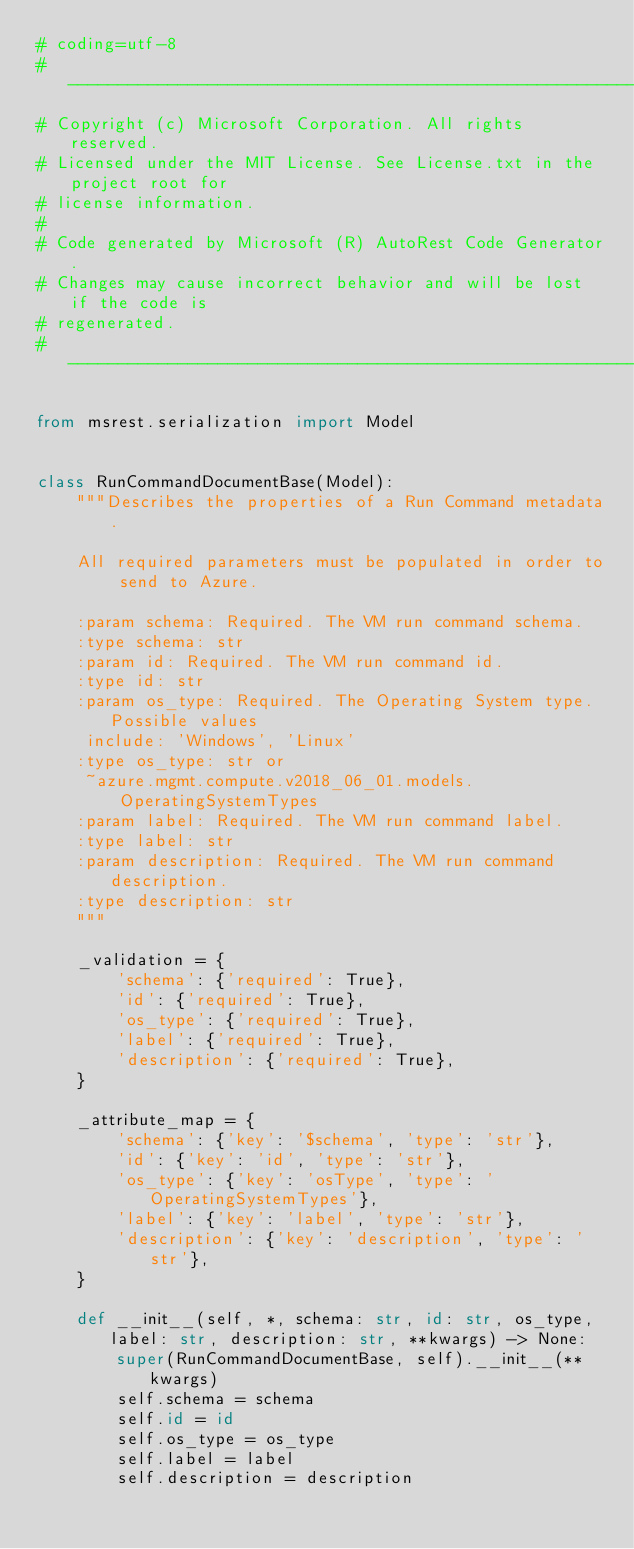<code> <loc_0><loc_0><loc_500><loc_500><_Python_># coding=utf-8
# --------------------------------------------------------------------------
# Copyright (c) Microsoft Corporation. All rights reserved.
# Licensed under the MIT License. See License.txt in the project root for
# license information.
#
# Code generated by Microsoft (R) AutoRest Code Generator.
# Changes may cause incorrect behavior and will be lost if the code is
# regenerated.
# --------------------------------------------------------------------------

from msrest.serialization import Model


class RunCommandDocumentBase(Model):
    """Describes the properties of a Run Command metadata.

    All required parameters must be populated in order to send to Azure.

    :param schema: Required. The VM run command schema.
    :type schema: str
    :param id: Required. The VM run command id.
    :type id: str
    :param os_type: Required. The Operating System type. Possible values
     include: 'Windows', 'Linux'
    :type os_type: str or
     ~azure.mgmt.compute.v2018_06_01.models.OperatingSystemTypes
    :param label: Required. The VM run command label.
    :type label: str
    :param description: Required. The VM run command description.
    :type description: str
    """

    _validation = {
        'schema': {'required': True},
        'id': {'required': True},
        'os_type': {'required': True},
        'label': {'required': True},
        'description': {'required': True},
    }

    _attribute_map = {
        'schema': {'key': '$schema', 'type': 'str'},
        'id': {'key': 'id', 'type': 'str'},
        'os_type': {'key': 'osType', 'type': 'OperatingSystemTypes'},
        'label': {'key': 'label', 'type': 'str'},
        'description': {'key': 'description', 'type': 'str'},
    }

    def __init__(self, *, schema: str, id: str, os_type, label: str, description: str, **kwargs) -> None:
        super(RunCommandDocumentBase, self).__init__(**kwargs)
        self.schema = schema
        self.id = id
        self.os_type = os_type
        self.label = label
        self.description = description
</code> 